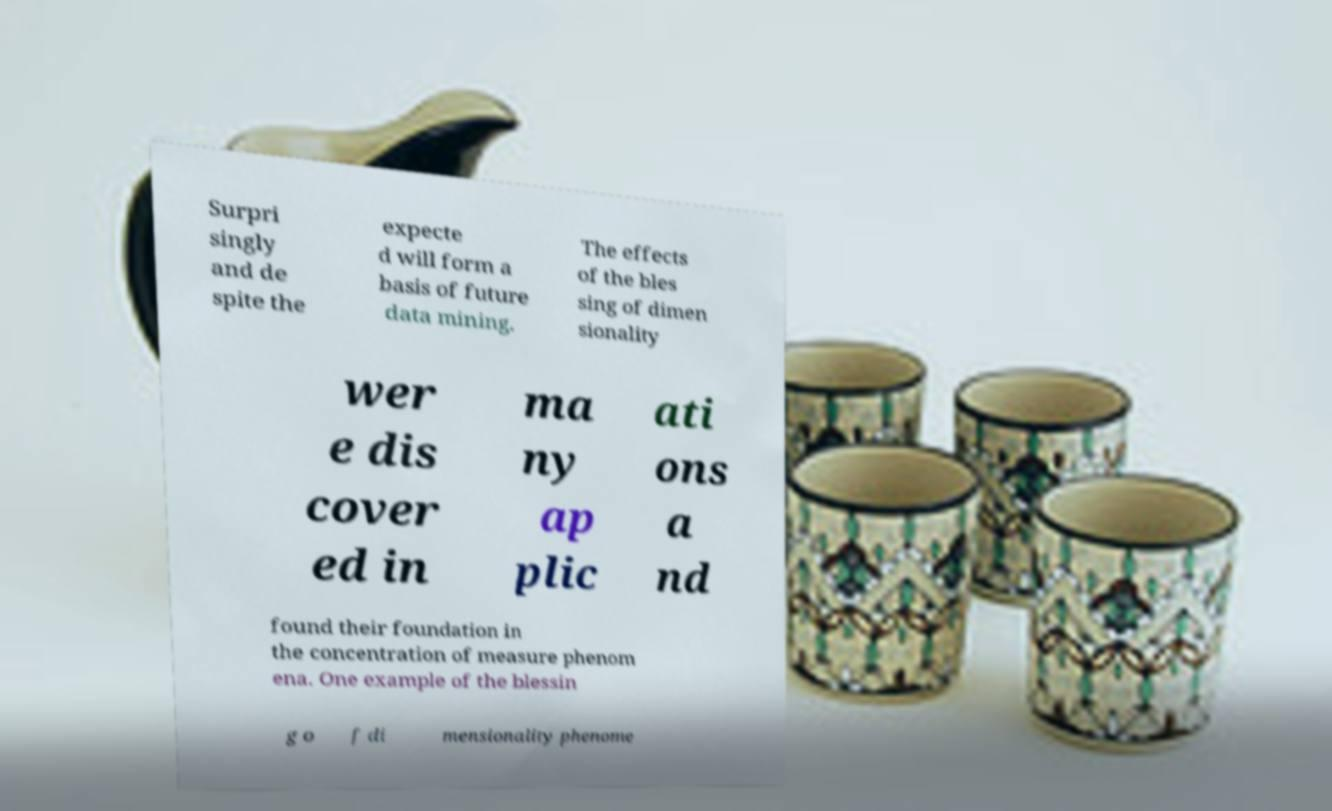Please read and relay the text visible in this image. What does it say? Surpri singly and de spite the expecte d will form a basis of future data mining. The effects of the bles sing of dimen sionality wer e dis cover ed in ma ny ap plic ati ons a nd found their foundation in the concentration of measure phenom ena. One example of the blessin g o f di mensionality phenome 